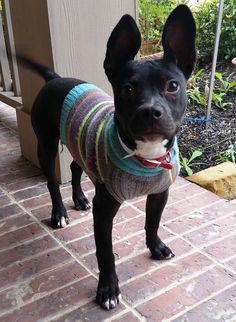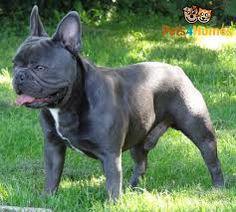The first image is the image on the left, the second image is the image on the right. Given the left and right images, does the statement "In one of the images a dog is wearing an object." hold true? Answer yes or no. Yes. The first image is the image on the left, the second image is the image on the right. Considering the images on both sides, is "One dog has its tongue out." valid? Answer yes or no. Yes. 